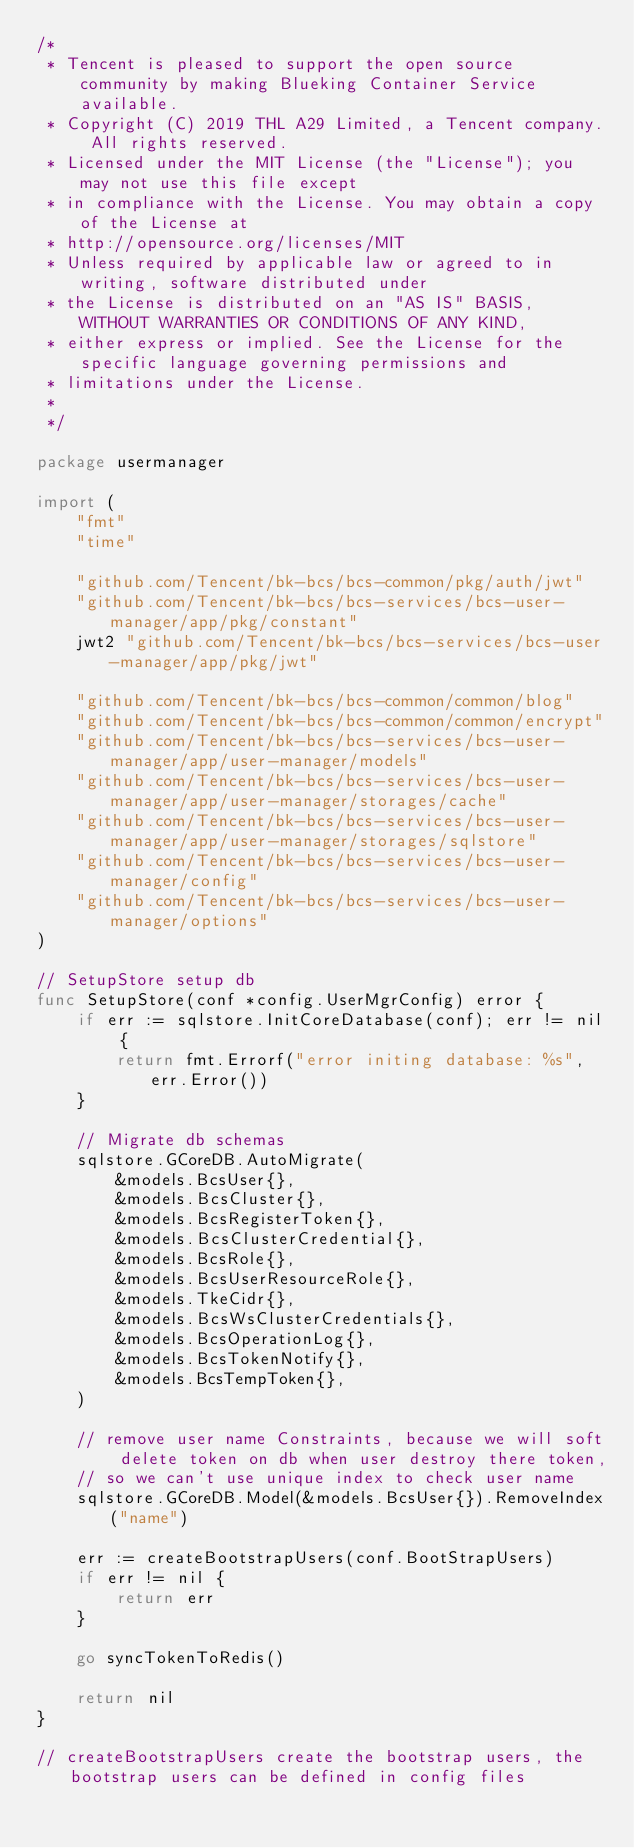<code> <loc_0><loc_0><loc_500><loc_500><_Go_>/*
 * Tencent is pleased to support the open source community by making Blueking Container Service available.
 * Copyright (C) 2019 THL A29 Limited, a Tencent company. All rights reserved.
 * Licensed under the MIT License (the "License"); you may not use this file except
 * in compliance with the License. You may obtain a copy of the License at
 * http://opensource.org/licenses/MIT
 * Unless required by applicable law or agreed to in writing, software distributed under
 * the License is distributed on an "AS IS" BASIS, WITHOUT WARRANTIES OR CONDITIONS OF ANY KIND,
 * either express or implied. See the License for the specific language governing permissions and
 * limitations under the License.
 *
 */

package usermanager

import (
	"fmt"
	"time"

	"github.com/Tencent/bk-bcs/bcs-common/pkg/auth/jwt"
	"github.com/Tencent/bk-bcs/bcs-services/bcs-user-manager/app/pkg/constant"
	jwt2 "github.com/Tencent/bk-bcs/bcs-services/bcs-user-manager/app/pkg/jwt"

	"github.com/Tencent/bk-bcs/bcs-common/common/blog"
	"github.com/Tencent/bk-bcs/bcs-common/common/encrypt"
	"github.com/Tencent/bk-bcs/bcs-services/bcs-user-manager/app/user-manager/models"
	"github.com/Tencent/bk-bcs/bcs-services/bcs-user-manager/app/user-manager/storages/cache"
	"github.com/Tencent/bk-bcs/bcs-services/bcs-user-manager/app/user-manager/storages/sqlstore"
	"github.com/Tencent/bk-bcs/bcs-services/bcs-user-manager/config"
	"github.com/Tencent/bk-bcs/bcs-services/bcs-user-manager/options"
)

// SetupStore setup db
func SetupStore(conf *config.UserMgrConfig) error {
	if err := sqlstore.InitCoreDatabase(conf); err != nil {
		return fmt.Errorf("error initing database: %s", err.Error())
	}

	// Migrate db schemas
	sqlstore.GCoreDB.AutoMigrate(
		&models.BcsUser{},
		&models.BcsCluster{},
		&models.BcsRegisterToken{},
		&models.BcsClusterCredential{},
		&models.BcsRole{},
		&models.BcsUserResourceRole{},
		&models.TkeCidr{},
		&models.BcsWsClusterCredentials{},
		&models.BcsOperationLog{},
		&models.BcsTokenNotify{},
		&models.BcsTempToken{},
	)

	// remove user name Constraints, because we will soft delete token on db when user destroy there token,
	// so we can't use unique index to check user name
	sqlstore.GCoreDB.Model(&models.BcsUser{}).RemoveIndex("name")

	err := createBootstrapUsers(conf.BootStrapUsers)
	if err != nil {
		return err
	}

	go syncTokenToRedis()

	return nil
}

// createBootstrapUsers create the bootstrap users, the bootstrap users can be defined in config files</code> 